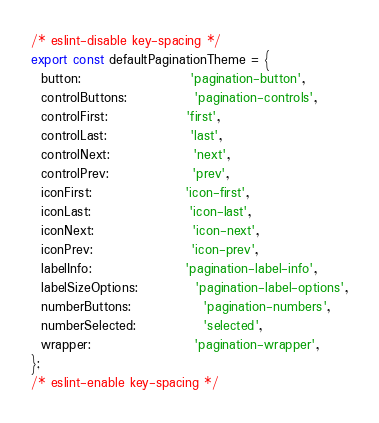Convert code to text. <code><loc_0><loc_0><loc_500><loc_500><_TypeScript_>/* eslint-disable key-spacing */
export const defaultPaginationTheme = {
  button:                     'pagination-button',
  controlButtons:             'pagination-controls',
  controlFirst:               'first',
  controlLast:                'last',
  controlNext:                'next',
  controlPrev:                'prev',
  iconFirst:                  'icon-first',
  iconLast:                   'icon-last',
  iconNext:                   'icon-next',
  iconPrev:                   'icon-prev',
  labelInfo:                  'pagination-label-info',
  labelSizeOptions:           'pagination-label-options',
  numberButtons:              'pagination-numbers',
  numberSelected:             'selected',
  wrapper:                    'pagination-wrapper',
};
/* eslint-enable key-spacing */
</code> 